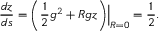<formula> <loc_0><loc_0><loc_500><loc_500>\frac { d z } { d s } = \Big . \left ( \frac { 1 } { 2 } g ^ { 2 } + R g z \right ) \Big | _ { R = 0 } = \frac { 1 } { 2 } .</formula> 